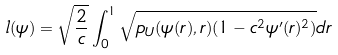<formula> <loc_0><loc_0><loc_500><loc_500>l ( \psi ) = \sqrt { \frac { 2 } { c } } \int _ { 0 } ^ { 1 } \sqrt { p _ { U } ( \psi ( r ) , r ) ( 1 - c ^ { 2 } \psi ^ { \prime } ( r ) ^ { 2 } ) } d r</formula> 